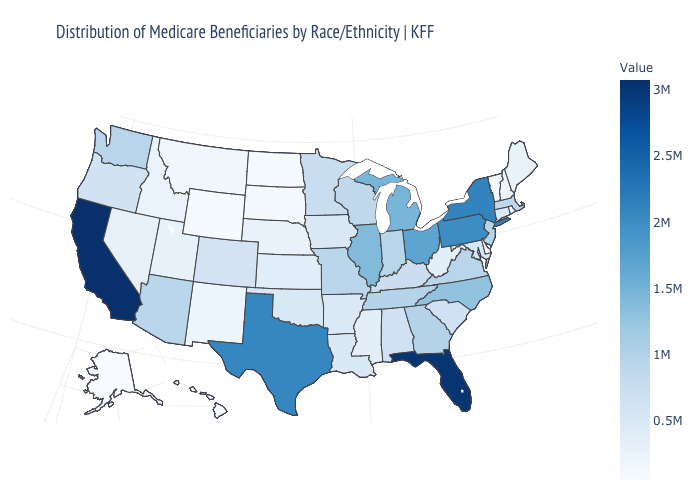Is the legend a continuous bar?
Give a very brief answer. Yes. Which states have the lowest value in the USA?
Short answer required. Alaska. Which states have the lowest value in the USA?
Quick response, please. Alaska. Does the map have missing data?
Concise answer only. No. Which states hav the highest value in the Northeast?
Concise answer only. New York. Among the states that border Michigan , does Wisconsin have the lowest value?
Write a very short answer. Yes. 